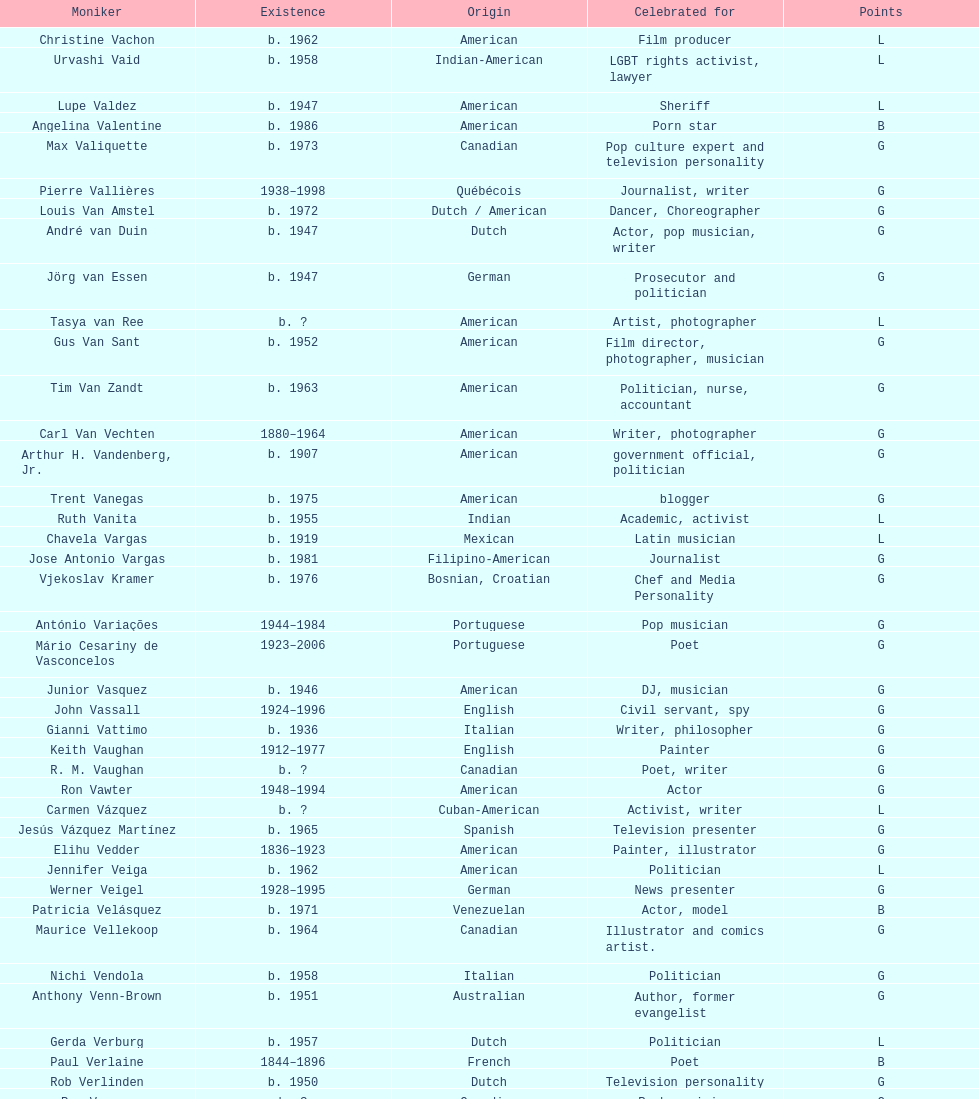Which nationality had the larger amount of names listed? American. 